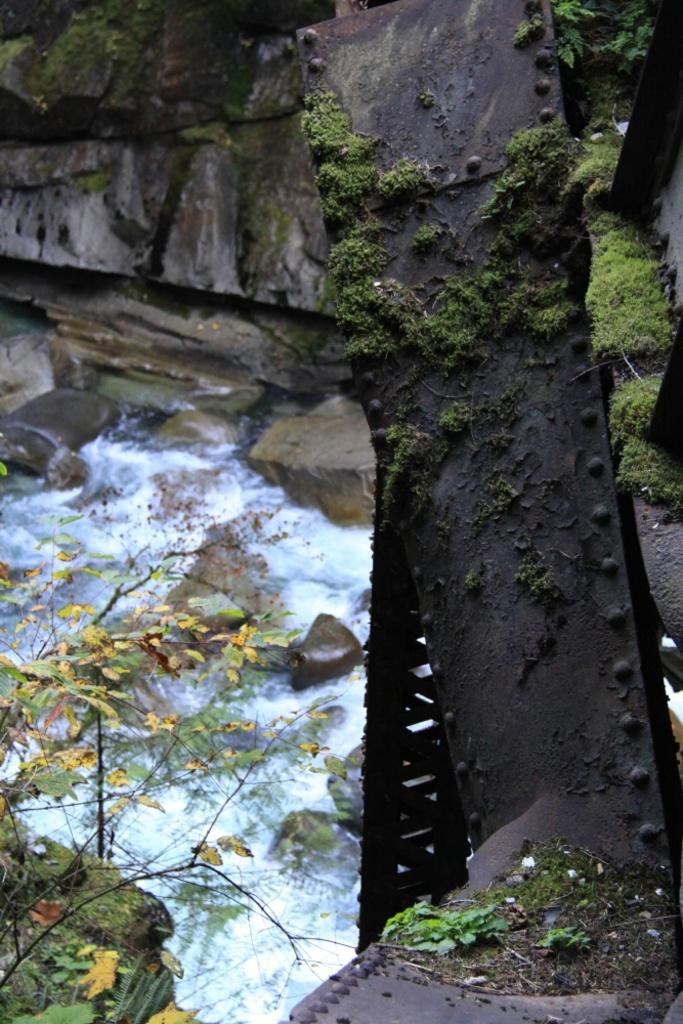What is the main structure in the image? There is a stand made of metal in the image. What is happening at the bottom of the stand? Water is flowing at the bottom of the stand. What can be seen in the background of the image? There are rocks in the background of the image. Where is the plant located in the image? There is a plant at the bottom left of the image. What type of property is being discussed in the image? There is no discussion of property in the image; it features a metal stand with water flowing at the bottom and a plant at the bottom left. How does the image depict the winter season? The image does not depict the winter season; there is no mention or indication of snow, ice, or cold weather. 